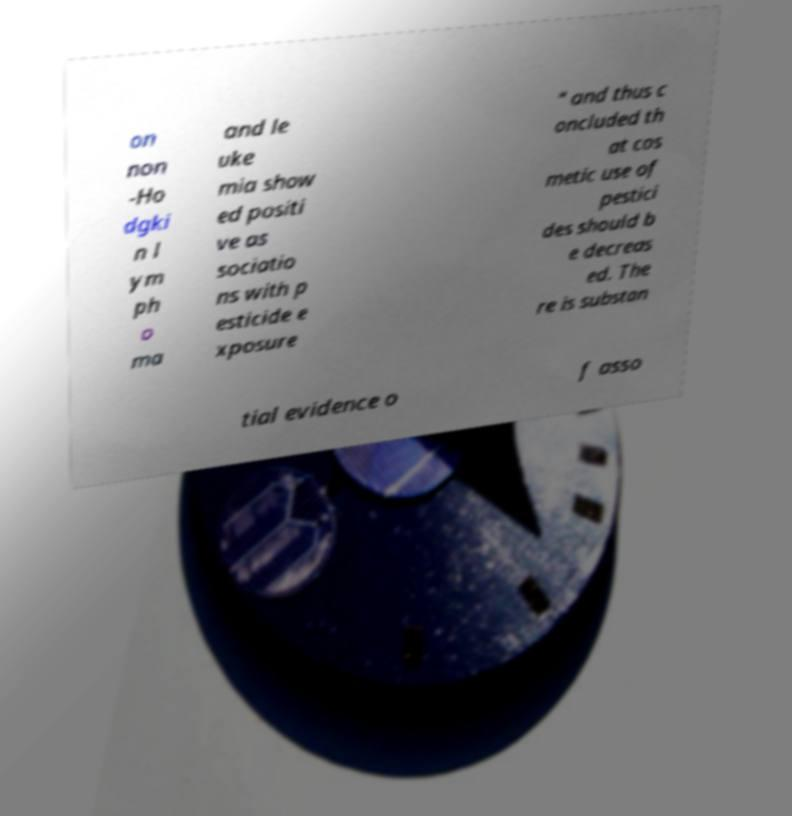Please identify and transcribe the text found in this image. on non -Ho dgki n l ym ph o ma and le uke mia show ed positi ve as sociatio ns with p esticide e xposure " and thus c oncluded th at cos metic use of pestici des should b e decreas ed. The re is substan tial evidence o f asso 